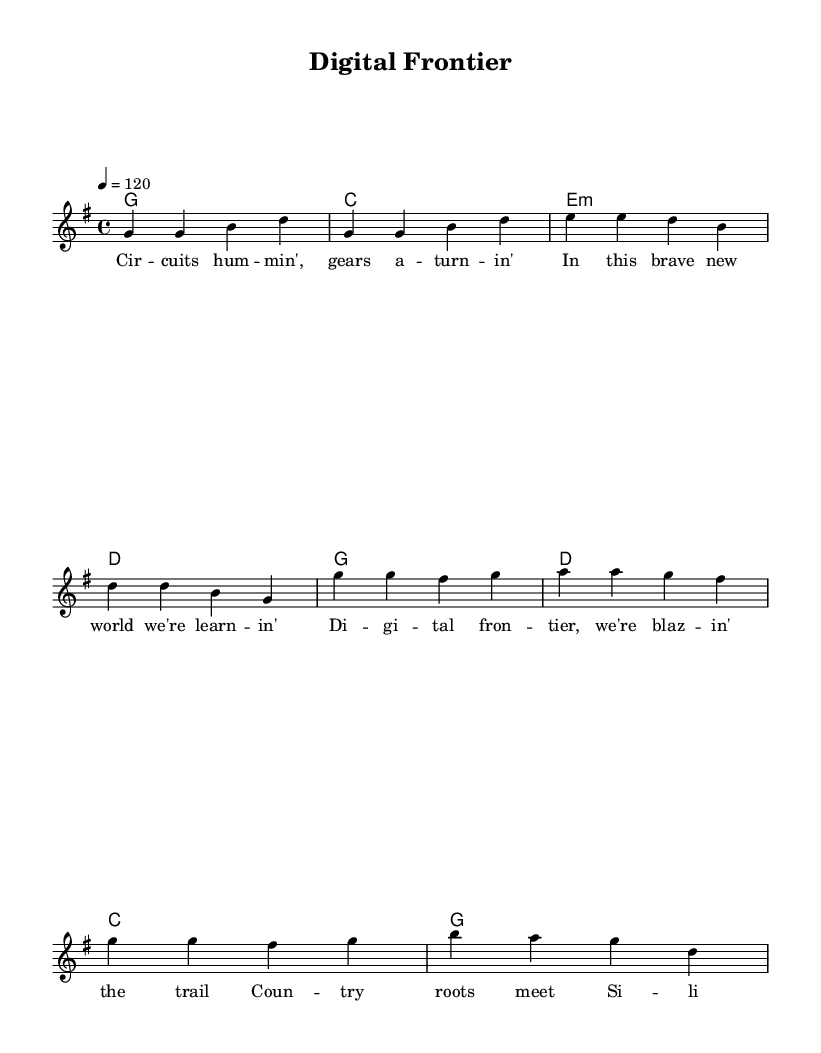What is the key signature of this music? The key signature is G major, which has one sharp (F#). It can be identified in the beginning of the sheet music, typically indicated by the number of sharps or flats before the treble staff.
Answer: G major What is the time signature of this piece? The time signature is 4/4, which means there are four beats in each measure and the quarter note gets one beat. This can be seen at the beginning of the sheet music next to the key signature.
Answer: 4/4 What is the tempo marking for this song? The tempo marking indicates a speed of 120 beats per minute, which is noted at the beginning of the score. This suggests a moderately fast tempo suitable for upbeat country rock.
Answer: 120 How many measures are in the verse section? The verse consists of four measures, which can be counted from the melody section. Each line of lyrics corresponds to one measure in the sheet music.
Answer: 4 Which chord is used in the first measure of the verse? The first measure of the verse contains the G major chord, as indicated in the harmonies section. It can be recognized as the first chord listed.
Answer: G What style of music does this anthem represent? This anthem represents Country Rock, a genre characterized by its upbeat tempo and themes relevant to country life and technological progress. The lyrical content and chord progressions align with this style.
Answer: Country Rock What does the chorus suggest about the theme of the song? The chorus suggests a theme of celebration around technological progress intertwined with country roots, as indicated through the lyrics referencing "Digital frontier" and "Country roots." This highlights a blending of traditional and modern elements.
Answer: Celebration of technology 